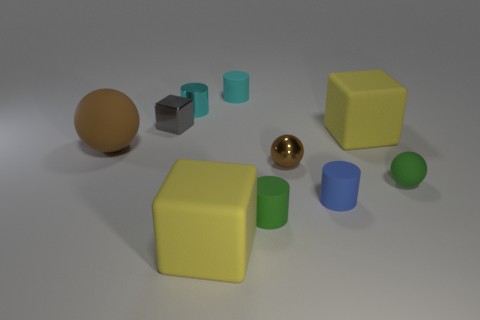How many brown balls must be subtracted to get 1 brown balls? 1 Subtract all purple cylinders. Subtract all cyan cubes. How many cylinders are left? 4 Subtract all cylinders. How many objects are left? 6 Add 8 brown cylinders. How many brown cylinders exist? 8 Subtract 0 gray spheres. How many objects are left? 10 Subtract all large brown balls. Subtract all gray shiny cubes. How many objects are left? 8 Add 8 big brown matte balls. How many big brown matte balls are left? 9 